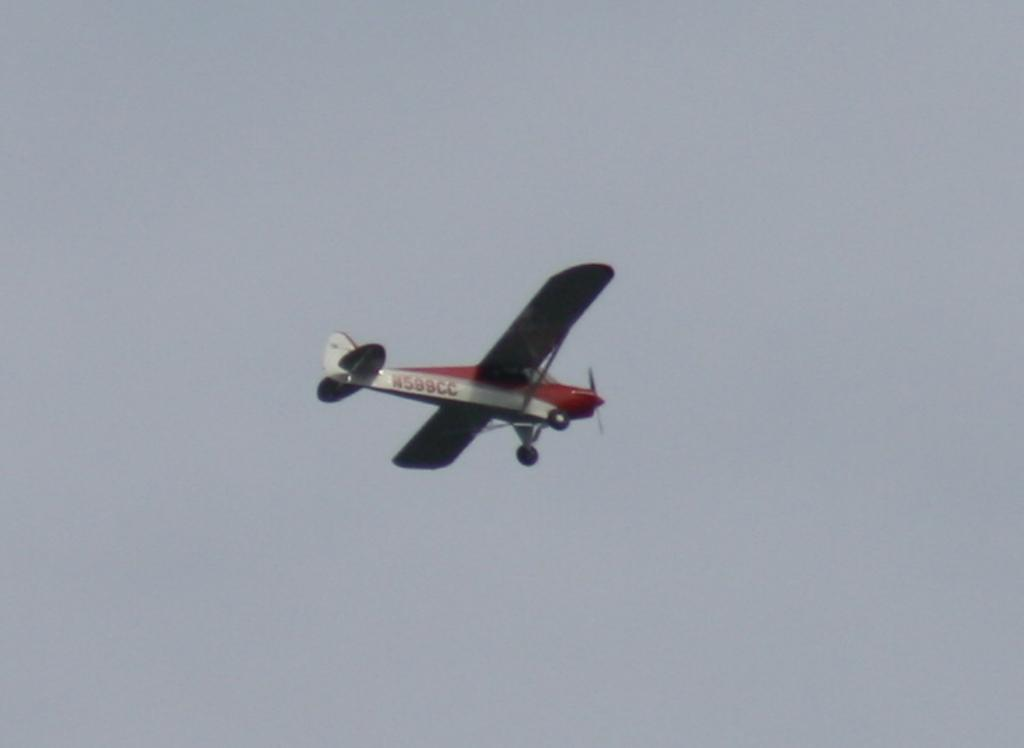What is the main subject of the image? The main subject of the image is an airplane. Where is the airplane located in the image? The airplane is in the sky. What type of pleasure can be seen being enjoyed by the glass in the image? There is no glass present in the image, and therefore no pleasure can be associated with it. 